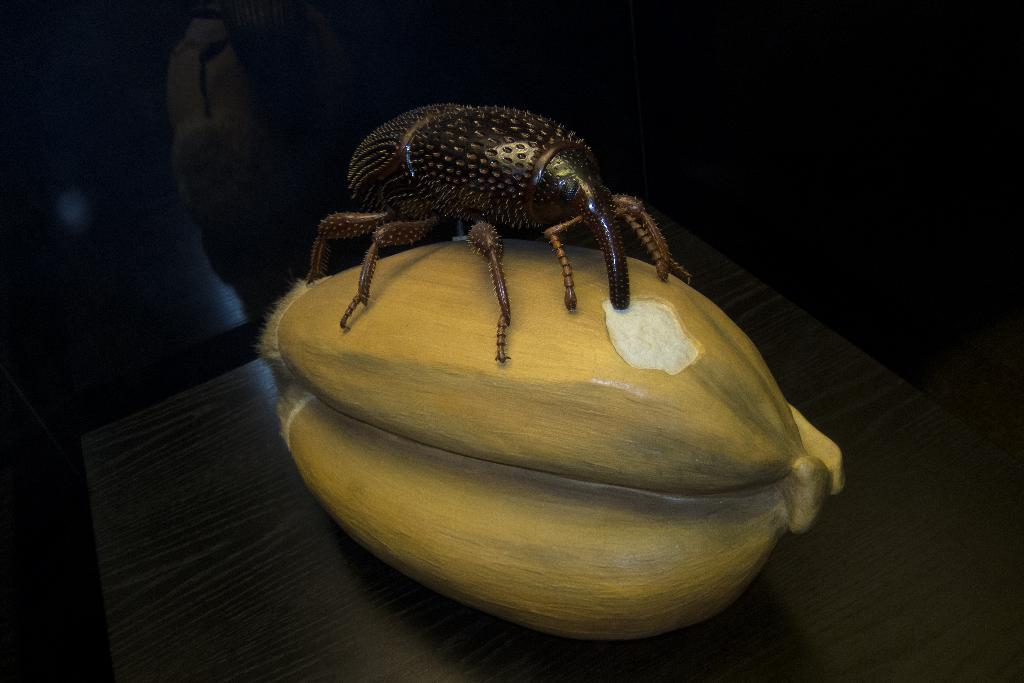What piece of furniture is in the image? There is a table in the image. What is on the table? There is a depiction of an insect on an object on the table. What type of seating is visible behind the table? There is a couch behind the table. How does the wind affect the insect's movement in the image? There is no wind present in the image, and the insect is a depiction, not a living creature, so its movement cannot be affected by wind. 